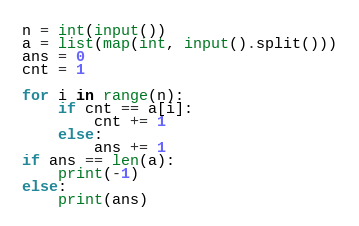<code> <loc_0><loc_0><loc_500><loc_500><_Python_>n = int(input())
a = list(map(int, input().split()))
ans = 0
cnt = 1

for i in range(n):
    if cnt == a[i]:
        cnt += 1
    else:
        ans += 1
if ans == len(a):
    print(-1)
else:
    print(ans)
</code> 